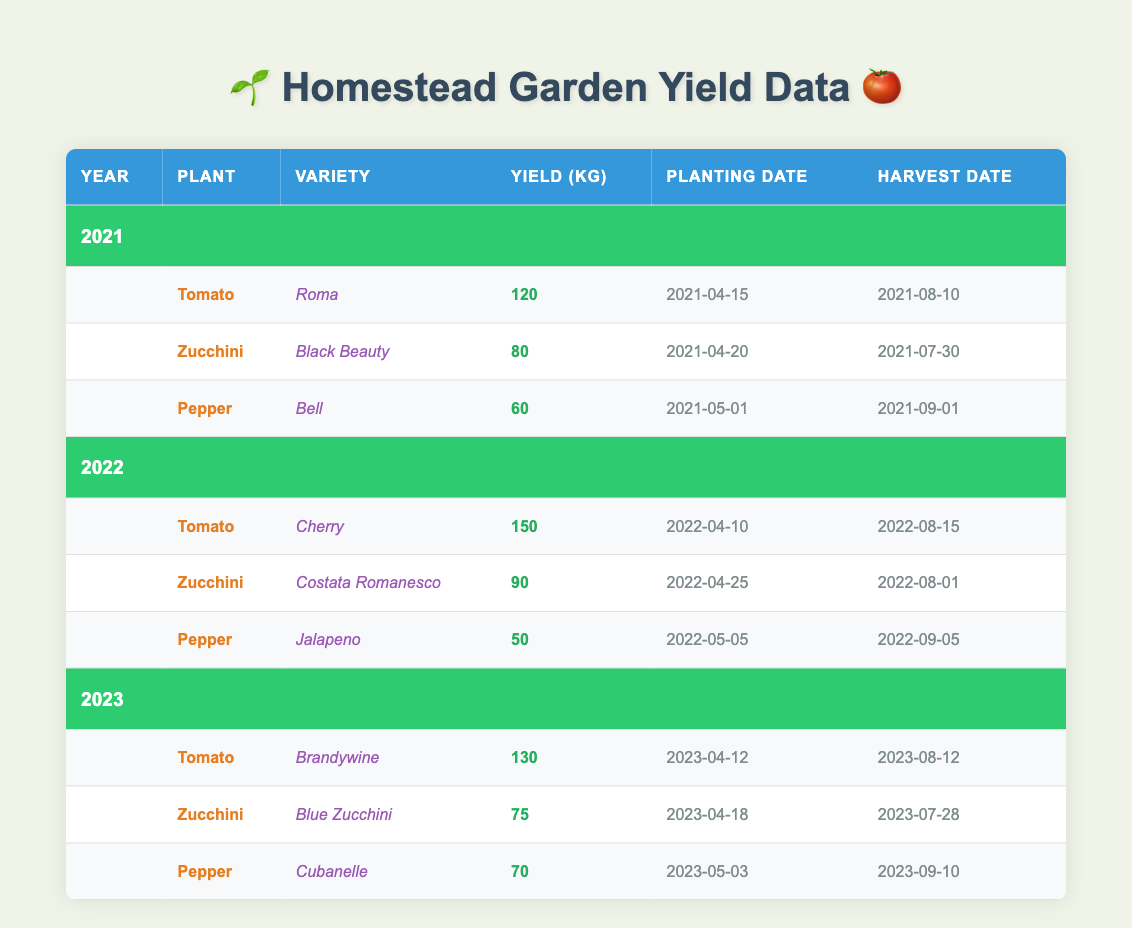What was the yield of Tomato in 2022? In 2022, the Tomato variety was Cherry, and its yield was listed as 150 kg in the table.
Answer: 150 kg Which variety of Zucchini had the highest yield and what was that yield? The Zucchini variety with the highest yield was Costata Romanesco from 2022, with a yield of 90 kg.
Answer: Costata Romanesco, 90 kg What is the total yield of all Peppers from 2021 to 2023? The yields of Peppers are 60 kg (2021) + 50 kg (2022) + 70 kg (2023) = 180 kg, so the total yield is 180 kg.
Answer: 180 kg Did the yield of Tomato increase or decrease from 2021 to 2023? The yield of Tomato in 2021 was 120 kg and in 2023 it was 130 kg, hence the yield increased by 10 kg.
Answer: Increased What was the average yield of Zucchini over the three years? The Zucchini yields were 80 kg (2021) + 90 kg (2022) + 75 kg (2023) = 245 kg, with 3 data points, the average is 245 kg / 3 = 81.67 kg.
Answer: 81.67 kg 